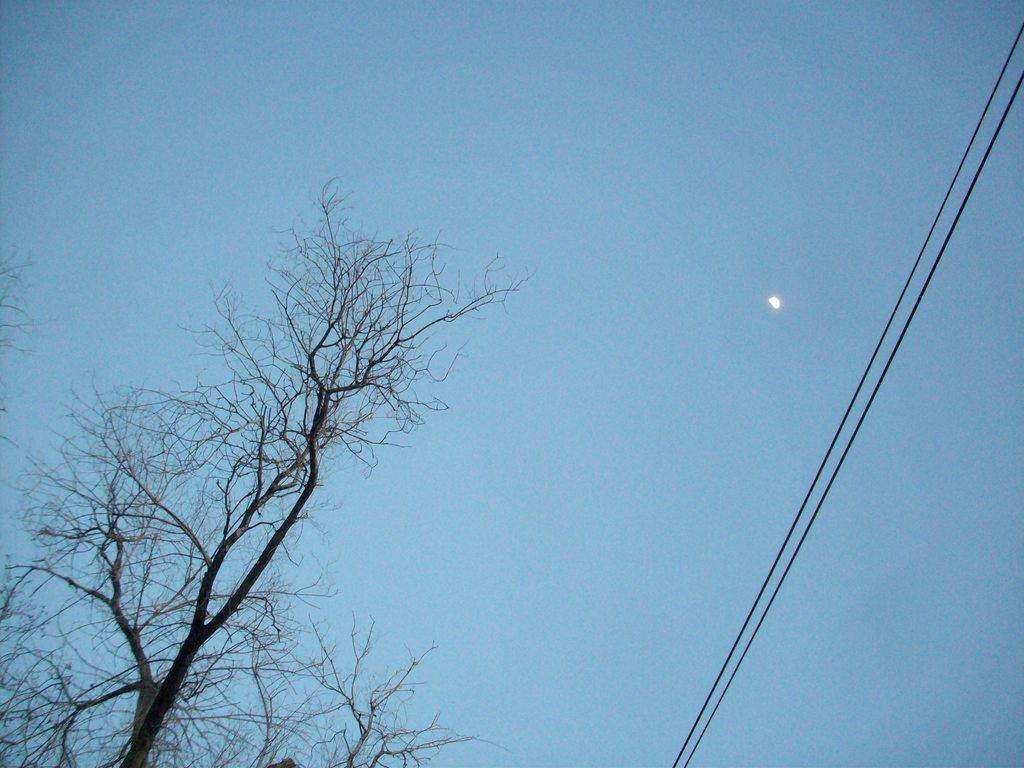What natural elements can be seen in the image? There are tree branches in the image. What man-made objects are present in the image? Electric wires are present in the image. What celestial body is visible in the image? There is a half moon visible in the image. What is the color of the sky in the image? The sky is pale blue in color. What type of iron is being used to support the tree branches in the image? There is no iron present in the image; the tree branches are supported by their own structure. 